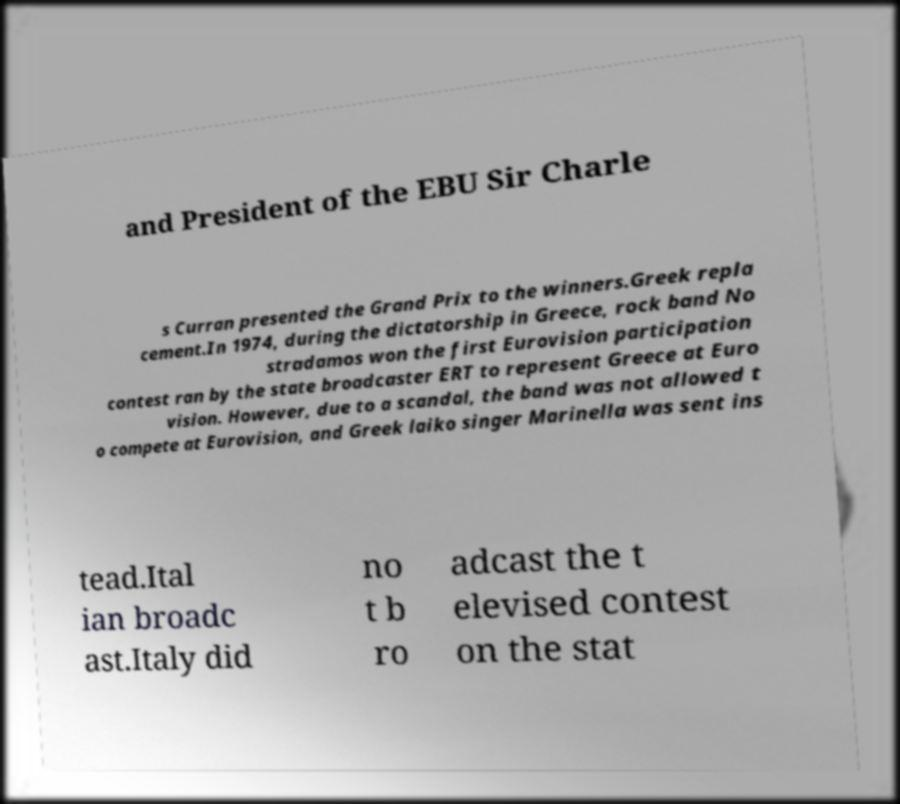What messages or text are displayed in this image? I need them in a readable, typed format. and President of the EBU Sir Charle s Curran presented the Grand Prix to the winners.Greek repla cement.In 1974, during the dictatorship in Greece, rock band No stradamos won the first Eurovision participation contest ran by the state broadcaster ERT to represent Greece at Euro vision. However, due to a scandal, the band was not allowed t o compete at Eurovision, and Greek laiko singer Marinella was sent ins tead.Ital ian broadc ast.Italy did no t b ro adcast the t elevised contest on the stat 